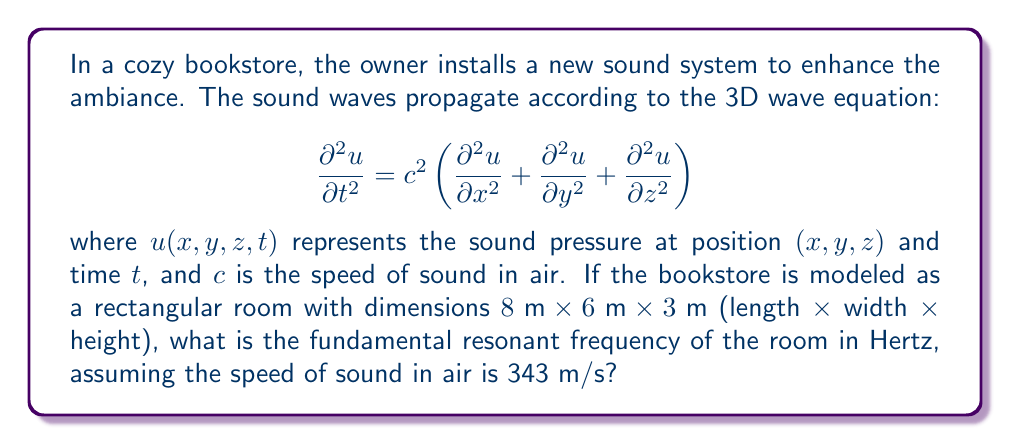Provide a solution to this math problem. To solve this problem, we'll follow these steps:

1) The fundamental resonant frequency of a rectangular room is given by the formula:

   $$f = \frac{c}{2} \sqrt{\left(\frac{n_x}{L_x}\right)^2 + \left(\frac{n_y}{L_y}\right)^2 + \left(\frac{n_z}{L_z}\right)^2}$$

   where $c$ is the speed of sound, $L_x$, $L_y$, and $L_z$ are the room dimensions, and $n_x$, $n_y$, and $n_z$ are integers representing the mode numbers.

2) For the fundamental frequency, we use the lowest possible mode numbers: $n_x = n_y = n_z = 1$.

3) We have:
   $c = 343 \text{ m/s}$
   $L_x = 8 \text{ m}$
   $L_y = 6 \text{ m}$
   $L_z = 3 \text{ m}$

4) Substituting these values into the equation:

   $$f = \frac{343}{2} \sqrt{\left(\frac{1}{8}\right)^2 + \left(\frac{1}{6}\right)^2 + \left(\frac{1}{3}\right)^2}$$

5) Simplifying:

   $$f = 171.5 \sqrt{\frac{1}{64} + \frac{1}{36} + \frac{1}{9}}$$
   $$f = 171.5 \sqrt{0.015625 + 0.027778 + 0.111111}$$
   $$f = 171.5 \sqrt{0.154514}$$
   $$f = 171.5 \times 0.393083$$
   $$f \approx 67.41 \text{ Hz}$$

6) Rounding to the nearest whole number:

   $$f \approx 67 \text{ Hz}$$
Answer: 67 Hz 